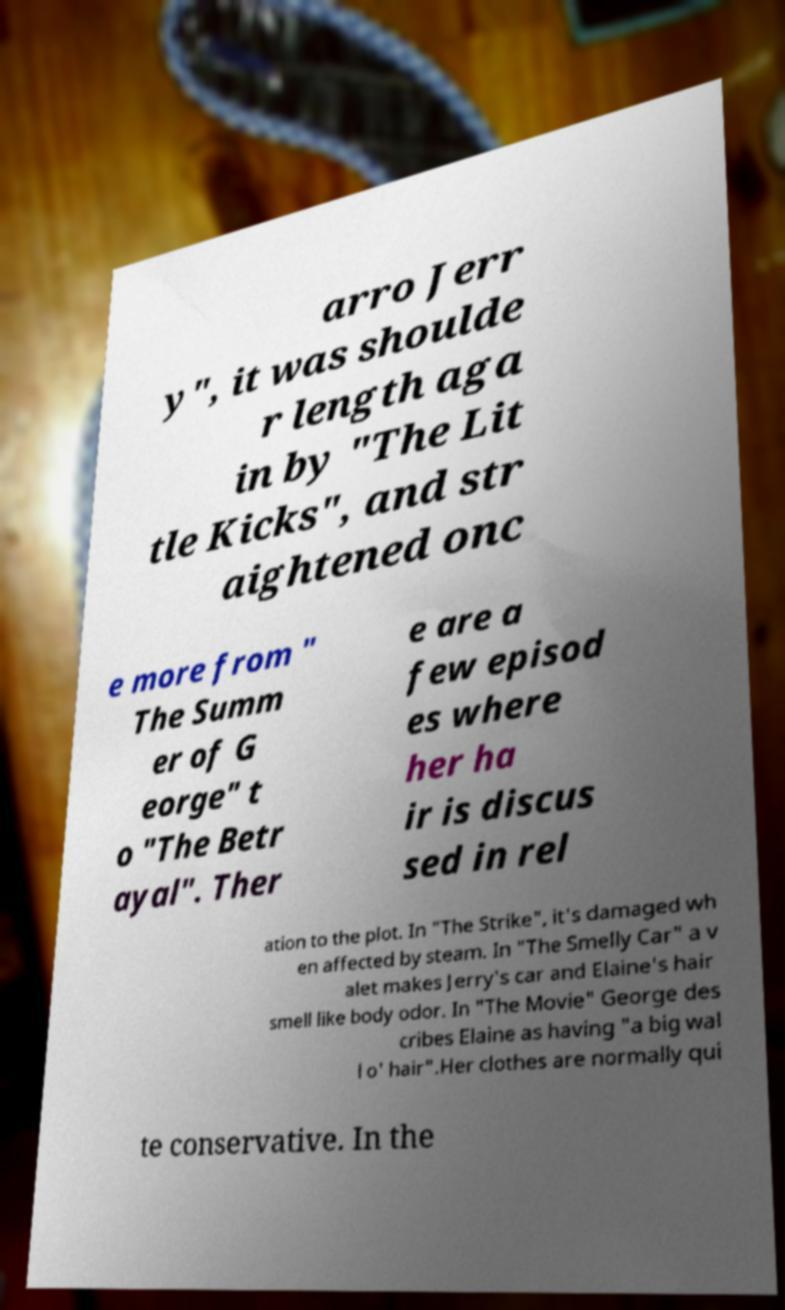Please read and relay the text visible in this image. What does it say? arro Jerr y", it was shoulde r length aga in by "The Lit tle Kicks", and str aightened onc e more from " The Summ er of G eorge" t o "The Betr ayal". Ther e are a few episod es where her ha ir is discus sed in rel ation to the plot. In "The Strike", it's damaged wh en affected by steam. In "The Smelly Car" a v alet makes Jerry's car and Elaine's hair smell like body odor. In "The Movie" George des cribes Elaine as having "a big wal l o' hair".Her clothes are normally qui te conservative. In the 